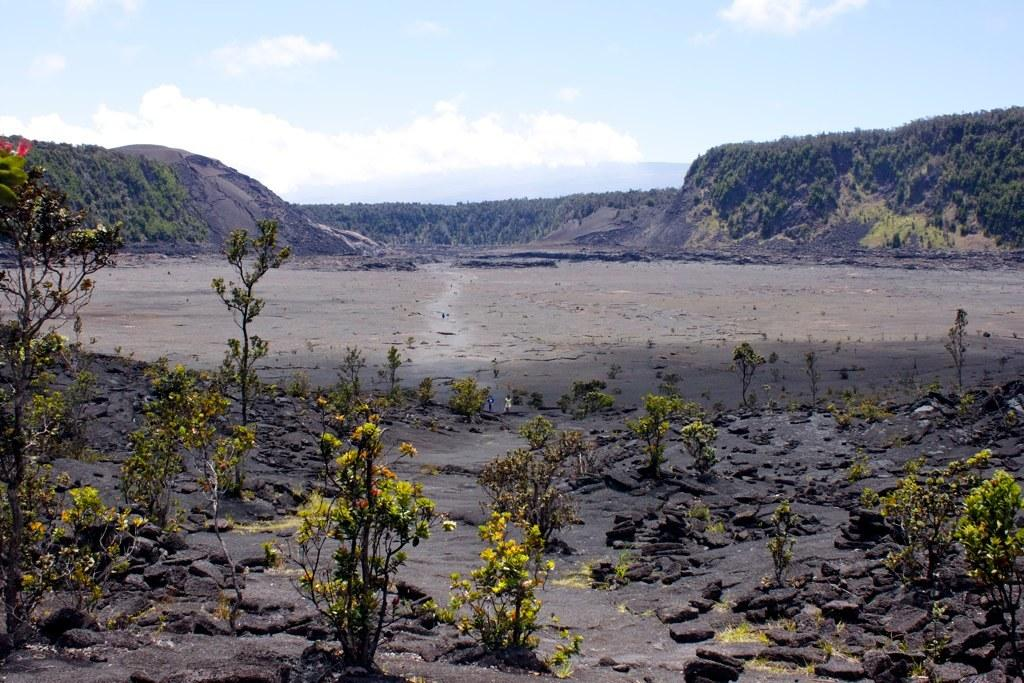What type of natural elements can be seen in the image? There are trees, plants, rocks, and hills visible in the image. Can you describe the sky in the image? The sky in the image has clouds visible. What type of terrain is depicted in the image? The image shows a hilly terrain with trees, plants, and rocks. What type of steel structure can be seen in the image? There is no steel structure present in the image; it features natural elements such as trees, plants, rocks, and hills. Are there any shoes visible in the image? There are no shoes present in the image. 